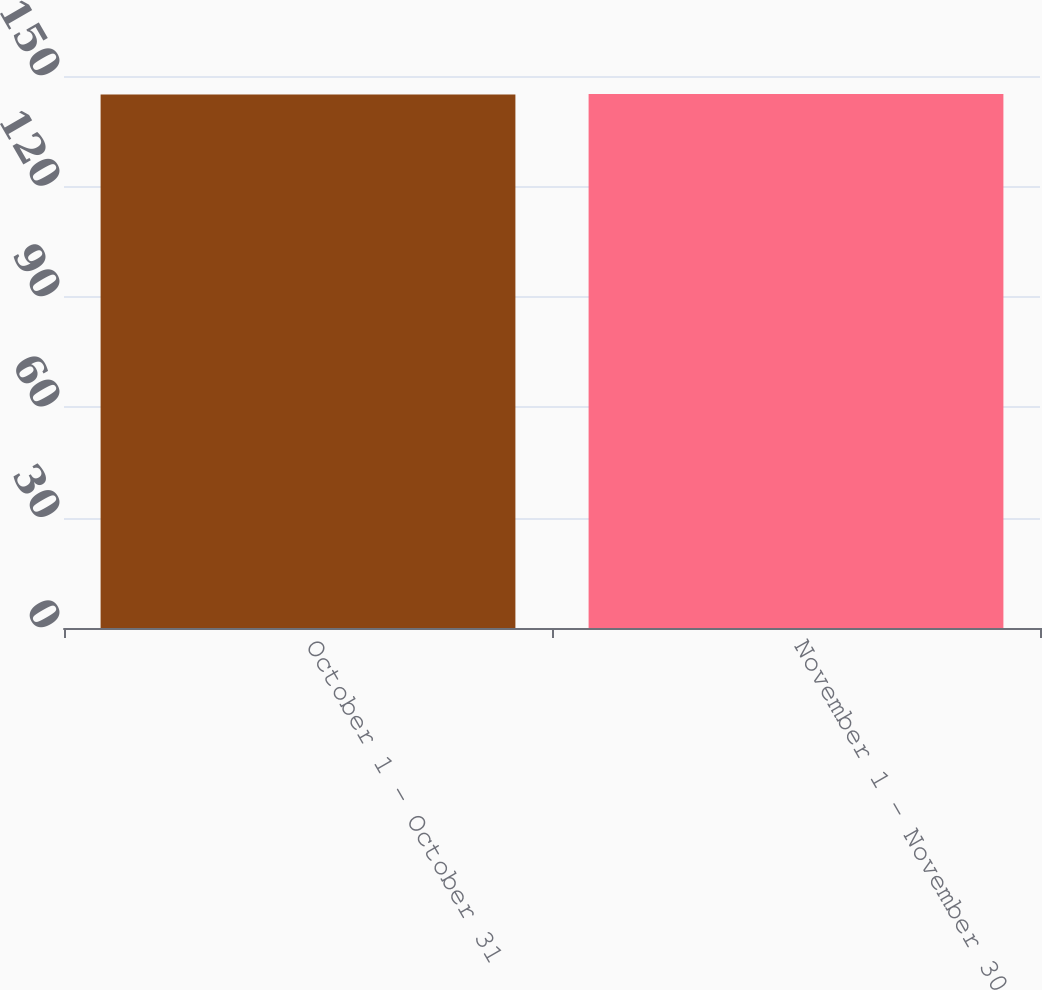Convert chart to OTSL. <chart><loc_0><loc_0><loc_500><loc_500><bar_chart><fcel>October 1 - October 31<fcel>November 1 - November 30<nl><fcel>145<fcel>145.1<nl></chart> 